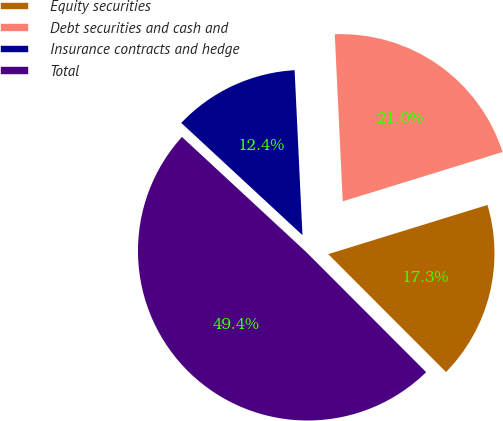Convert chart to OTSL. <chart><loc_0><loc_0><loc_500><loc_500><pie_chart><fcel>Equity securities<fcel>Debt securities and cash and<fcel>Insurance contracts and hedge<fcel>Total<nl><fcel>17.28%<fcel>20.99%<fcel>12.35%<fcel>49.38%<nl></chart> 